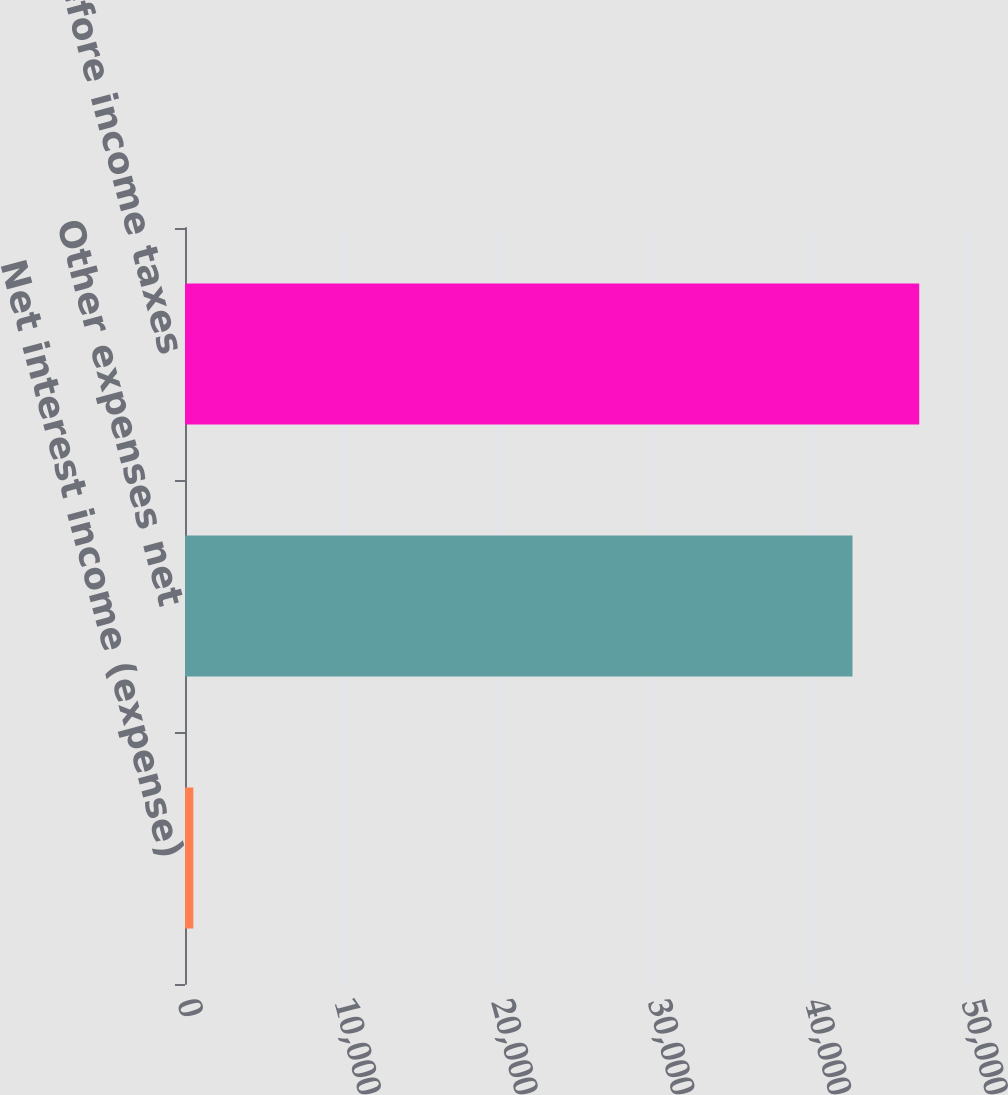Convert chart to OTSL. <chart><loc_0><loc_0><loc_500><loc_500><bar_chart><fcel>Net interest income (expense)<fcel>Other expenses net<fcel>Loss before income taxes<nl><fcel>531<fcel>42569<fcel>46825.9<nl></chart> 